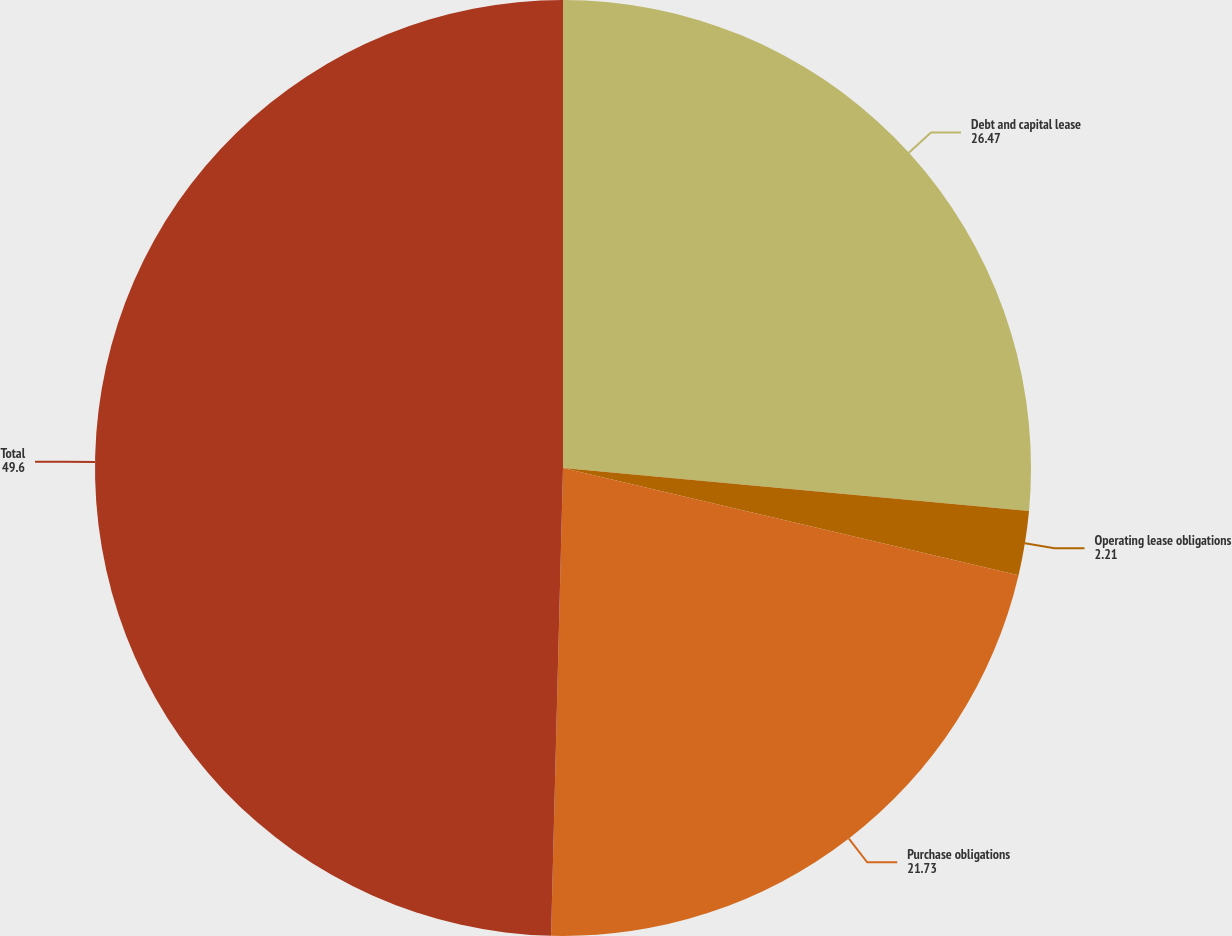<chart> <loc_0><loc_0><loc_500><loc_500><pie_chart><fcel>Debt and capital lease<fcel>Operating lease obligations<fcel>Purchase obligations<fcel>Total<nl><fcel>26.47%<fcel>2.21%<fcel>21.73%<fcel>49.6%<nl></chart> 